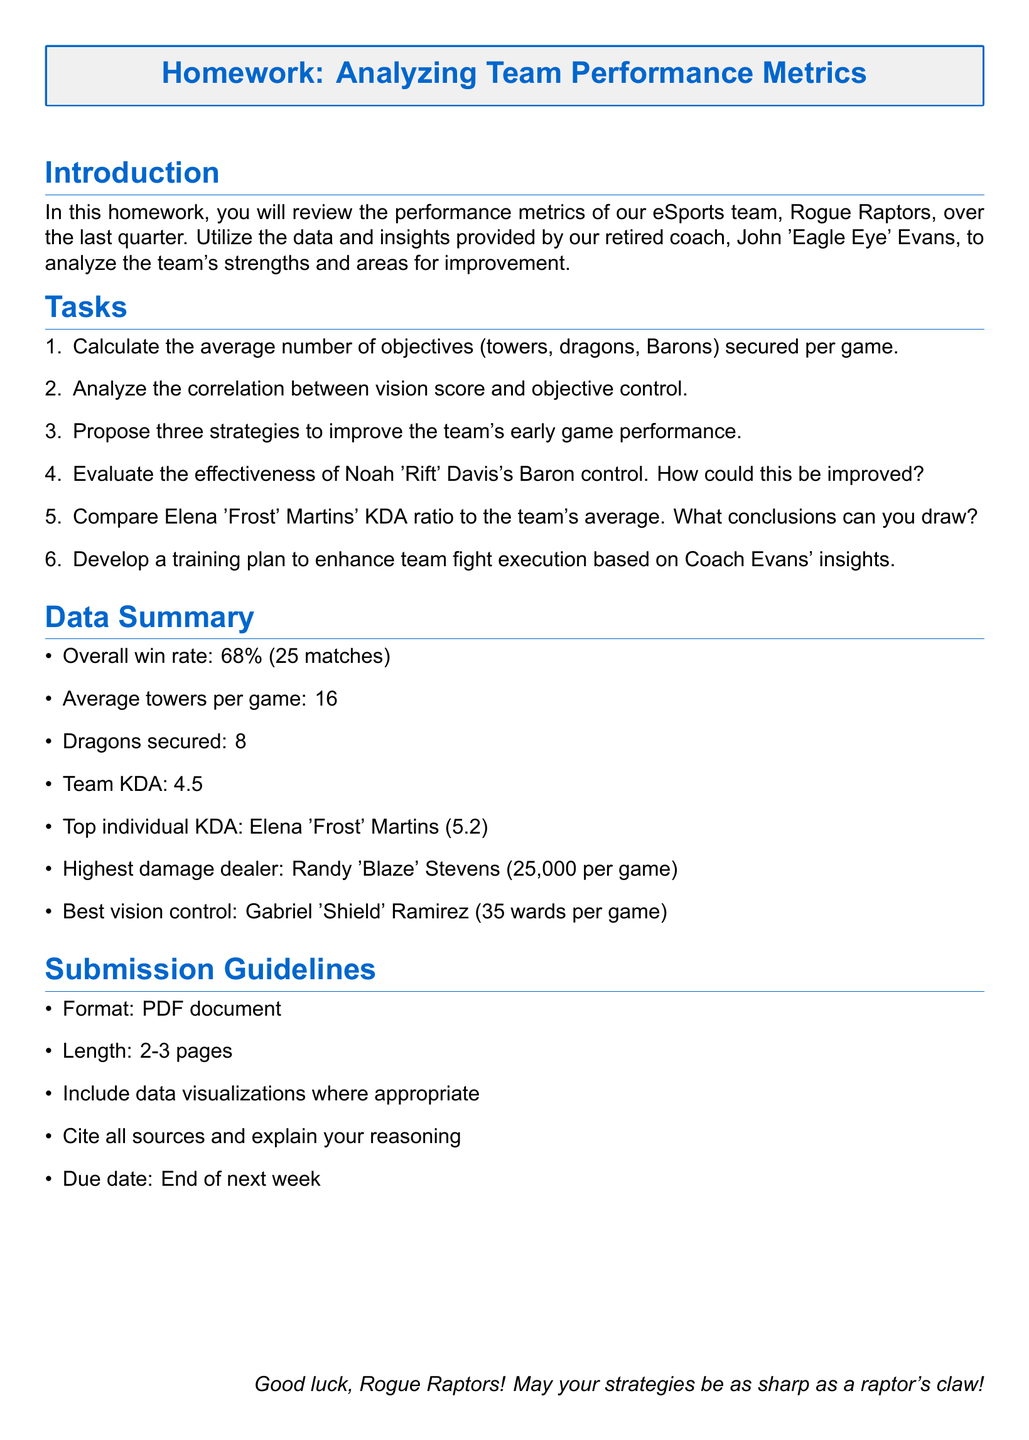What is the overall win rate of the team? The overall win rate is calculated from the matches played by the team, which is 68%.
Answer: 68% How many matches did the Rogue Raptors play? The number of matches played is mentioned in the data summary as 25 matches.
Answer: 25 What is the average towers secured per game? The average towers per game is explicitly stated in the document as 16.
Answer: 16 Who had the highest damage per game? The document specifies Randy 'Blaze' Stevens as the highest damage dealer with 25,000 per game.
Answer: Randy 'Blaze' Stevens What is Elena 'Frost' Martins' KDA ratio? The KDA ratio for Elena 'Frost' Martins is given in the data summary as 5.2.
Answer: 5.2 What are three proposed strategies to improve early game performance? The assignment requires proposing three strategies, but the specific strategies were not provided in the document.
Answer: N/A What is the best vision control score and who achieved it? Gabriel 'Shield' Ramirez is mentioned as having the best vision control with 35 wards per game.
Answer: 35 wards per game What is the required format for the homework submission? The format required for homework submission is clearly stated as a PDF document.
Answer: PDF document What is the due date for submission? The document mentions that the homework is due at the end of next week.
Answer: End of next week 